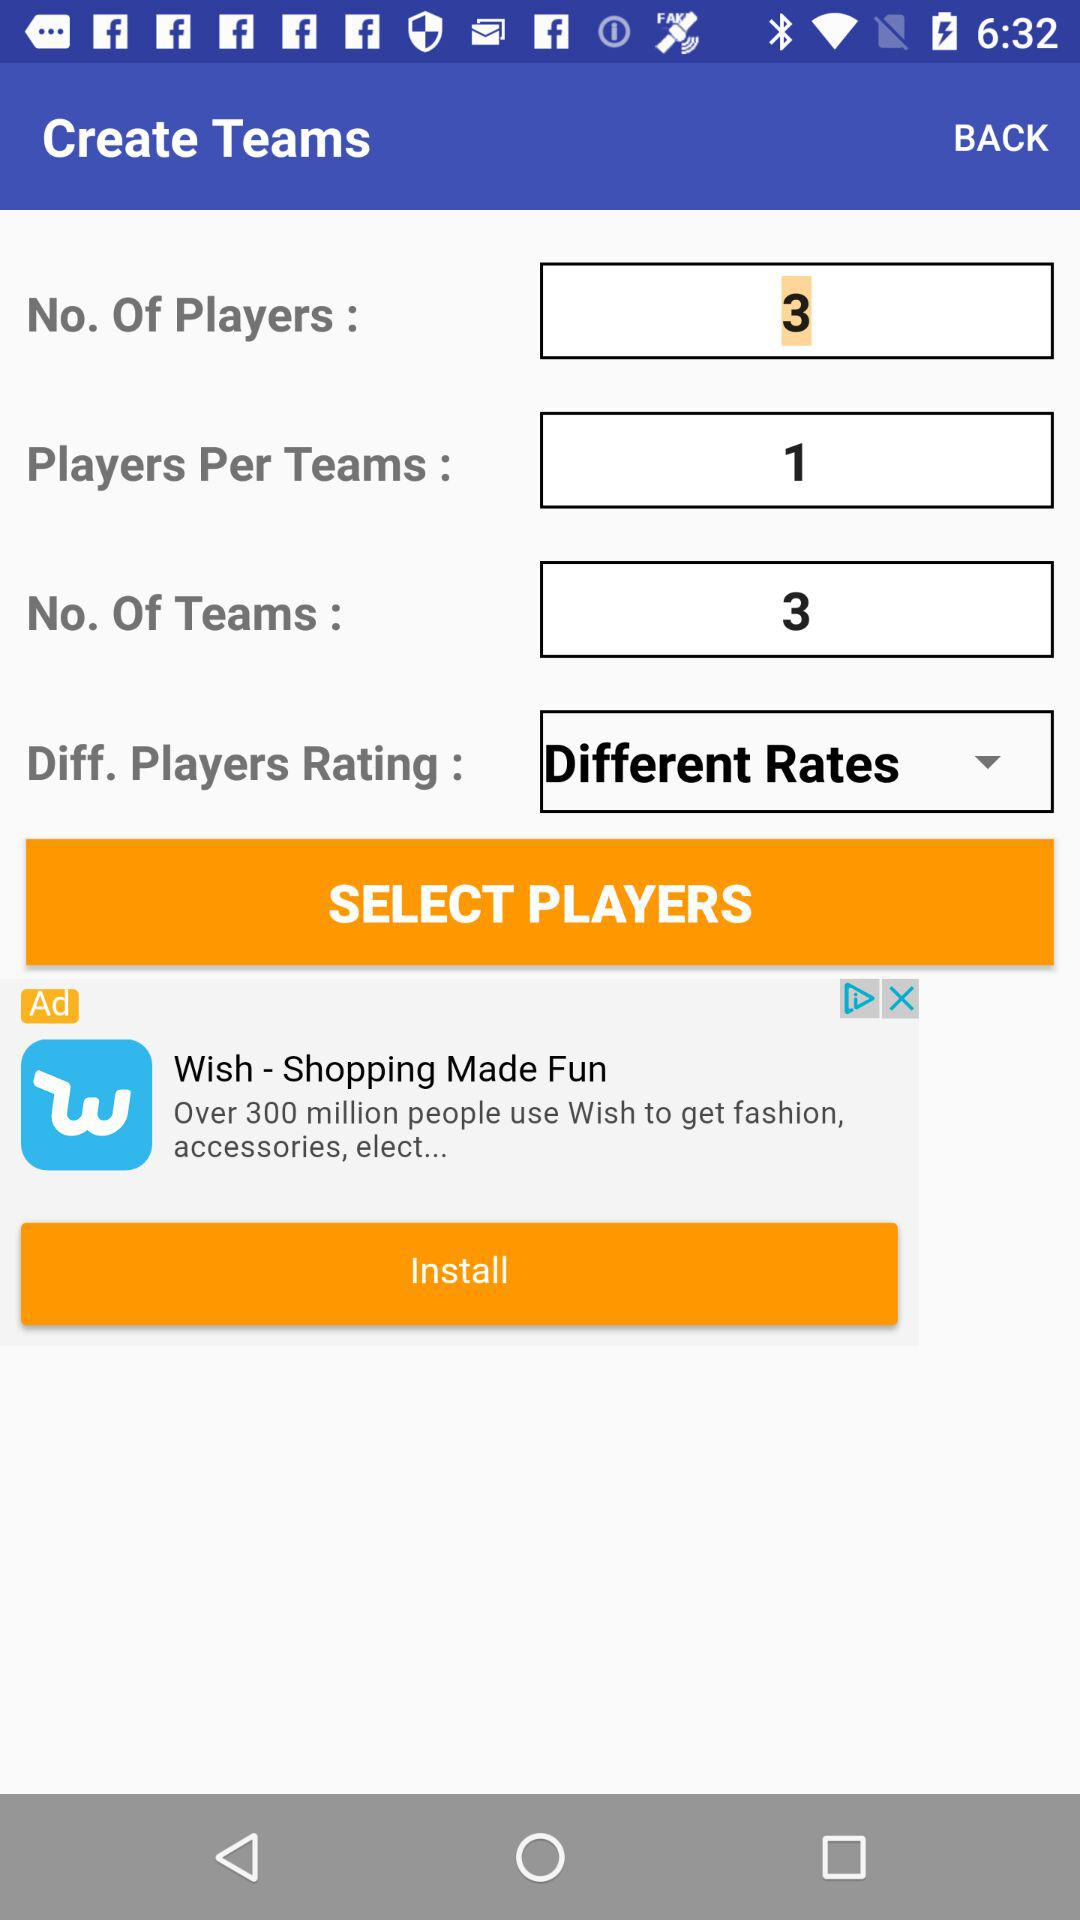What is the number of teams? The number of teams is 3. 